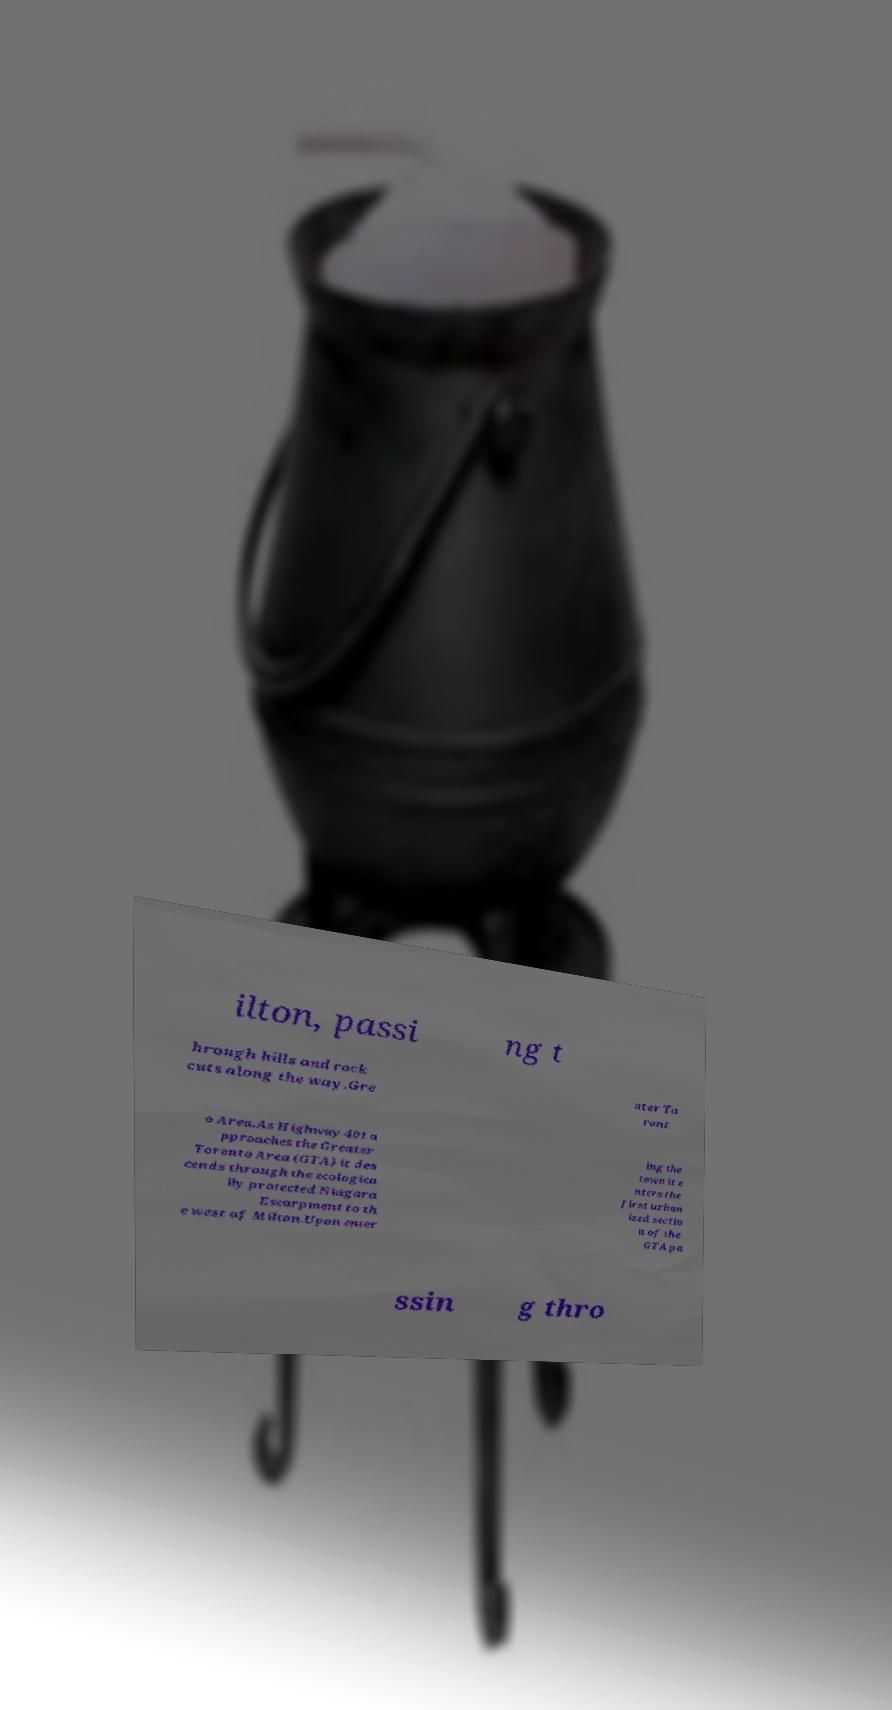Could you extract and type out the text from this image? ilton, passi ng t hrough hills and rock cuts along the way.Gre ater To ront o Area.As Highway 401 a pproaches the Greater Toronto Area (GTA) it des cends through the ecologica lly protected Niagara Escarpment to th e west of Milton.Upon enter ing the town it e nters the first urban ized sectio n of the GTA pa ssin g thro 